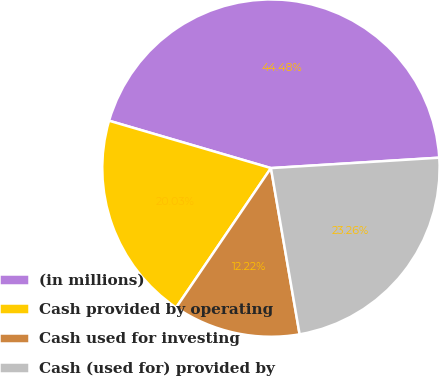Convert chart to OTSL. <chart><loc_0><loc_0><loc_500><loc_500><pie_chart><fcel>(in millions)<fcel>Cash provided by operating<fcel>Cash used for investing<fcel>Cash (used for) provided by<nl><fcel>44.48%<fcel>20.03%<fcel>12.22%<fcel>23.26%<nl></chart> 